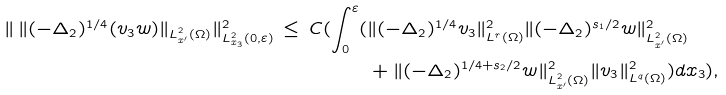Convert formula to latex. <formula><loc_0><loc_0><loc_500><loc_500>\| \, \| ( - \Delta _ { 2 } ) ^ { 1 / 4 } ( v _ { 3 } w ) \| _ { L ^ { 2 } _ { x ^ { \prime } } ( \Omega ) } \| ^ { 2 } _ { L ^ { 2 } _ { x _ { 3 } } ( 0 , \varepsilon ) } \, \leq \, C ( \int _ { 0 } ^ { \varepsilon } ( & \| ( - \Delta _ { 2 } ) ^ { 1 / 4 } v _ { 3 } \| ^ { 2 } _ { L ^ { r } ( \Omega ) } \| ( - \Delta _ { 2 } ) ^ { s _ { 1 } / 2 } w \| ^ { 2 } _ { L ^ { 2 } _ { x ^ { \prime } } ( \Omega ) } \\ & + \| ( - \Delta _ { 2 } ) ^ { 1 / 4 + s _ { 2 } / 2 } w \| ^ { 2 } _ { L ^ { 2 } _ { x ^ { \prime } } ( \Omega ) } \| v _ { 3 } \| ^ { 2 } _ { L ^ { q } ( \Omega ) } ) d x _ { 3 } ) ,</formula> 